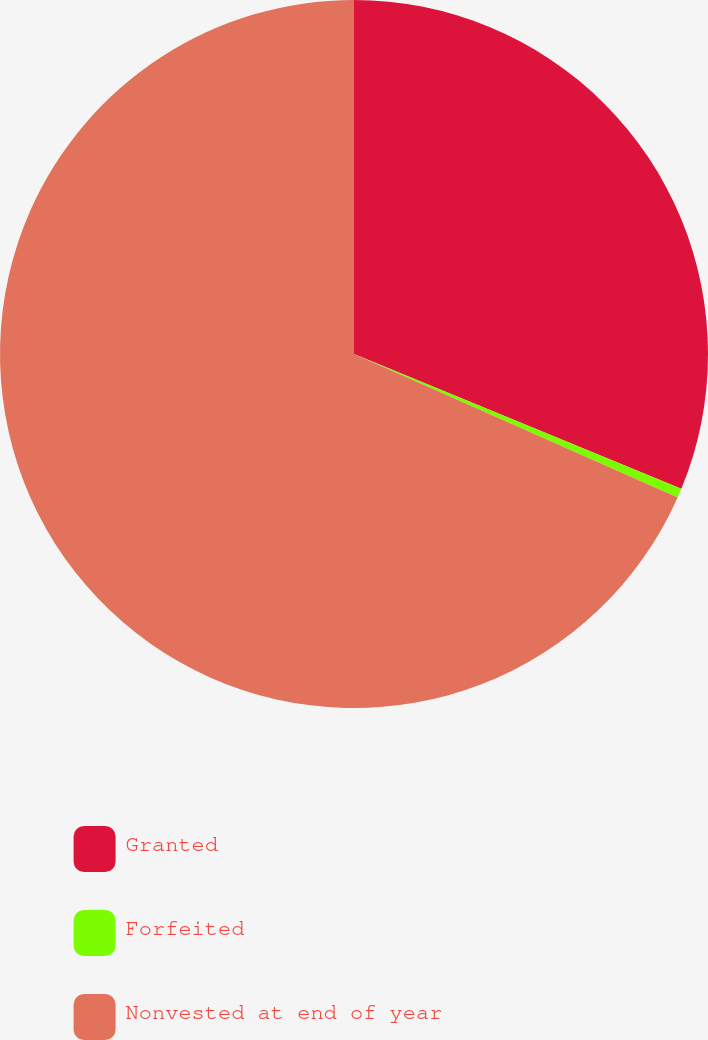Convert chart. <chart><loc_0><loc_0><loc_500><loc_500><pie_chart><fcel>Granted<fcel>Forfeited<fcel>Nonvested at end of year<nl><fcel>31.22%<fcel>0.42%<fcel>68.36%<nl></chart> 